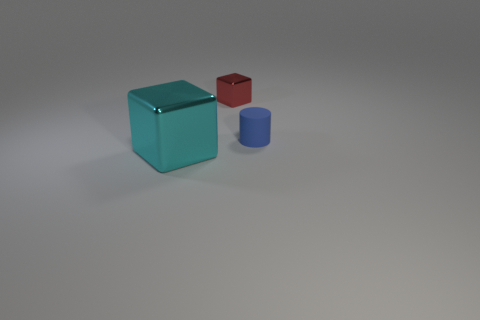Subtract all cylinders. How many objects are left? 2 Add 1 cyan shiny cubes. How many cyan shiny cubes exist? 2 Add 3 gray cylinders. How many objects exist? 6 Subtract 0 blue spheres. How many objects are left? 3 Subtract 1 blocks. How many blocks are left? 1 Subtract all gray blocks. Subtract all cyan cylinders. How many blocks are left? 2 Subtract all brown balls. How many red blocks are left? 1 Subtract all small blue objects. Subtract all blue matte cylinders. How many objects are left? 1 Add 2 blue rubber things. How many blue rubber things are left? 3 